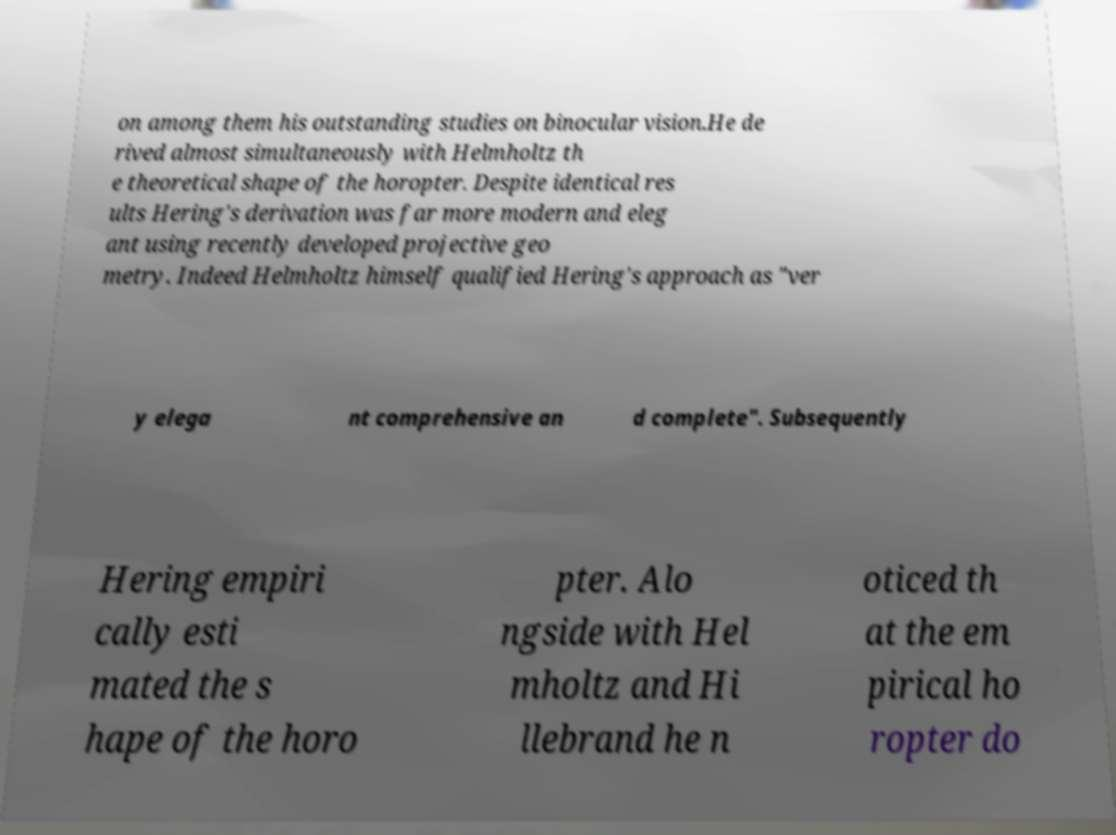What messages or text are displayed in this image? I need them in a readable, typed format. on among them his outstanding studies on binocular vision.He de rived almost simultaneously with Helmholtz th e theoretical shape of the horopter. Despite identical res ults Hering's derivation was far more modern and eleg ant using recently developed projective geo metry. Indeed Helmholtz himself qualified Hering's approach as "ver y elega nt comprehensive an d complete". Subsequently Hering empiri cally esti mated the s hape of the horo pter. Alo ngside with Hel mholtz and Hi llebrand he n oticed th at the em pirical ho ropter do 